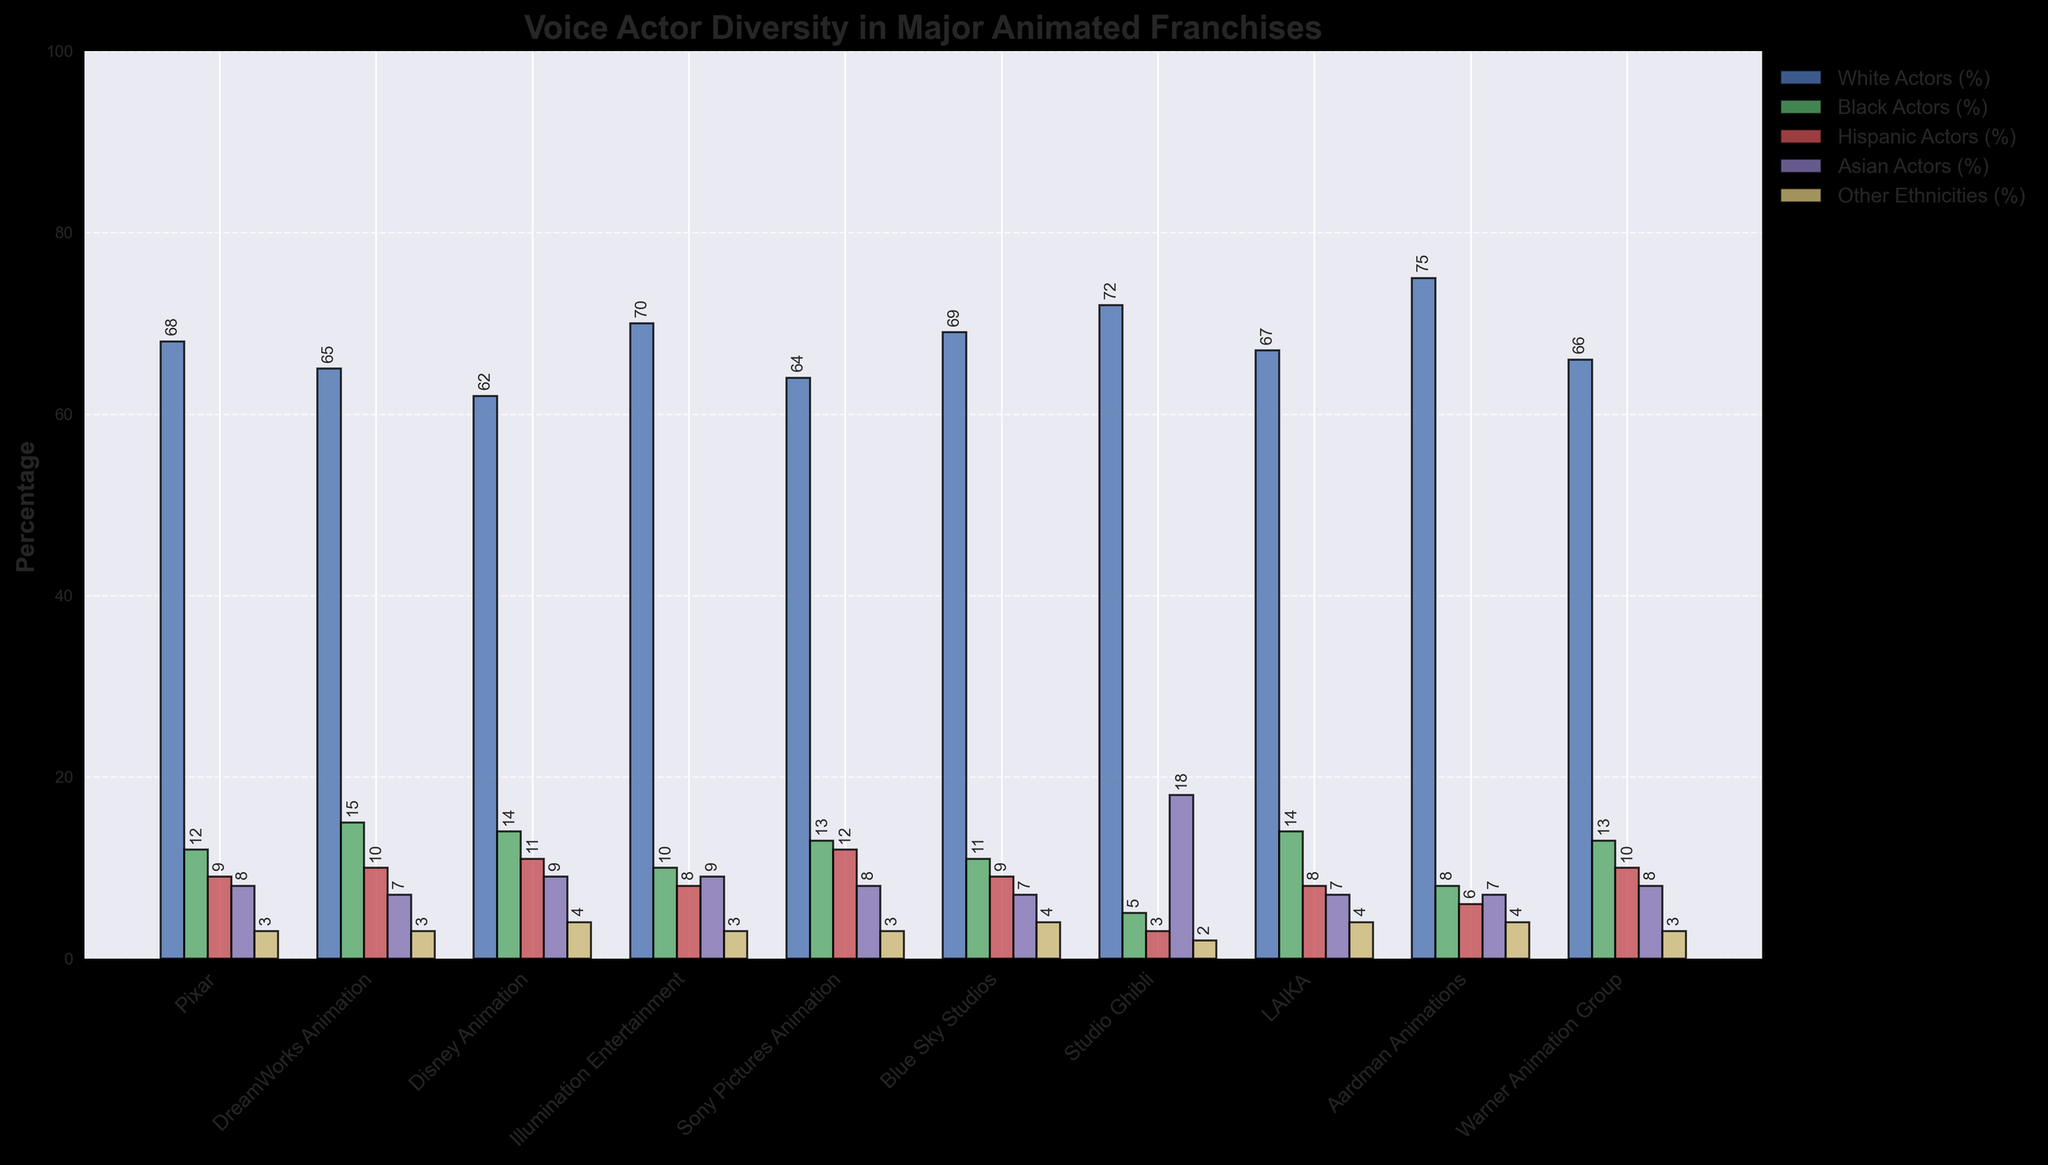What percentage of voice actors in Studio Ghibli are Asian actors? Look at the bar representing 'Asian Actors (%)' for Studio Ghibli. The height of the bar shows the percentage. The bar is labeled with a value of 18.
Answer: 18% Between which two franchises is the percentage of Hispanic actors exactly equal? Compare the heights of the bars representing 'Hispanic Actors (%)' in all franchises. The heights for Disney Animation and Sony Pictures Animation are both 12%.
Answer: Disney Animation and Sony Pictures Animation Which franchise has the lowest percentage of Black actors? Examine the bars representing 'Black Actors (%)' across all franchises. The shortest bar corresponds to Studio Ghibli with a value of 5%.
Answer: Studio Ghibli By how much does the percentage of White actors in Aardman Animations exceed that in DreamWorks Animation? Check the bars for 'White Actors (%)' for Aardman Animations and DreamWorks Animation. Subtract the value for DreamWorks (65) from the value for Aardman Animations (75).
Answer: 10% What is the total percentage of non-White actors in Pixar? Add the percentages of 'Black Actors (%)', 'Hispanic Actors (%)', 'Asian Actors (%)', and 'Other Ethnicities (%)' for Pixar (12 + 9 + 8 + 3).
Answer: 32% Which franchise has the highest overall percentage of non-White actors? Calculate the sum of non-White (Black, Hispanic, Asian, Other) actors' percentages for each franchise, and compare. Studio Ghibli has the highest sum (5 + 3 + 18 + 2 = 28).
Answer: Studio Ghibli How does the diversity representation of White actors in Blue Sky Studios compare to that in Illumination Entertainment? Compare the bar heights for 'White Actors (%)' between Blue Sky Studios and Illumination Entertainment. Blue Sky Studios has a value of 69, and Illumination Entertainment has a value of 70.
Answer: Blue Sky Studios is less by 1% What percentage of voice actors in LAIKA are from other ethnicities? Find the bar representing 'Other Ethnicities (%)' for LAIKA. The height of the bar shows a percentage value of 4.
Answer: 4% Which two franchises have the same percentage of Asian voice actors? Compare the heights of the bars representing 'Asian Actors (%)' across all franchises. Both Pixar and Sony Pictures Animation have a value of 8%.
Answer: Pixar and Sony Pictures Animation 